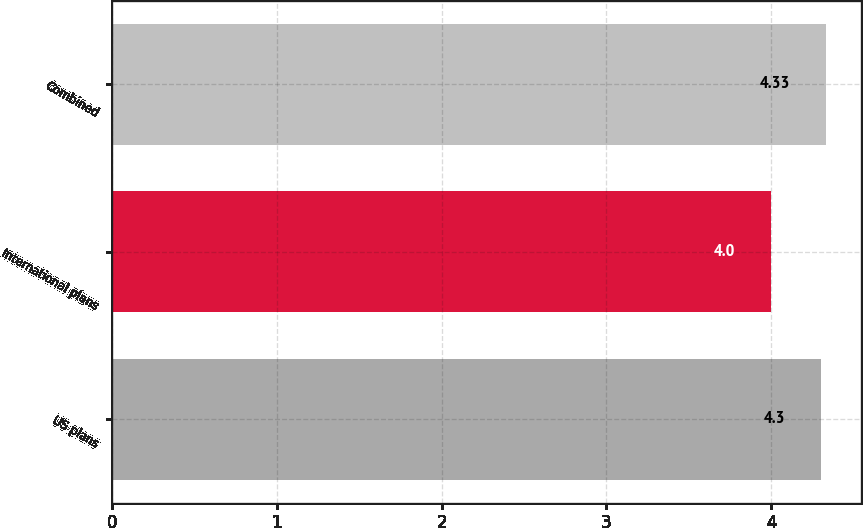<chart> <loc_0><loc_0><loc_500><loc_500><bar_chart><fcel>US plans<fcel>International plans<fcel>Combined<nl><fcel>4.3<fcel>4<fcel>4.33<nl></chart> 